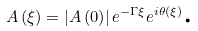Convert formula to latex. <formula><loc_0><loc_0><loc_500><loc_500>A \left ( \xi \right ) = \left | A \left ( 0 \right ) \right | e ^ { - \Gamma \xi } e ^ { i \theta \left ( \xi \right ) } \text {.}</formula> 